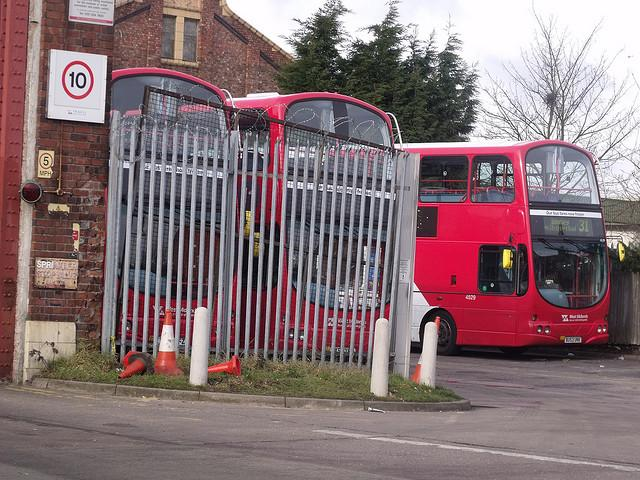Which side of the street do the busses seen here travel when driving forward?

Choices:
A) none
B) right
C) center only
D) left left 